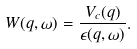<formula> <loc_0><loc_0><loc_500><loc_500>W ( q , \omega ) = \frac { V _ { c } ( q ) } { \epsilon ( q , \omega ) } .</formula> 